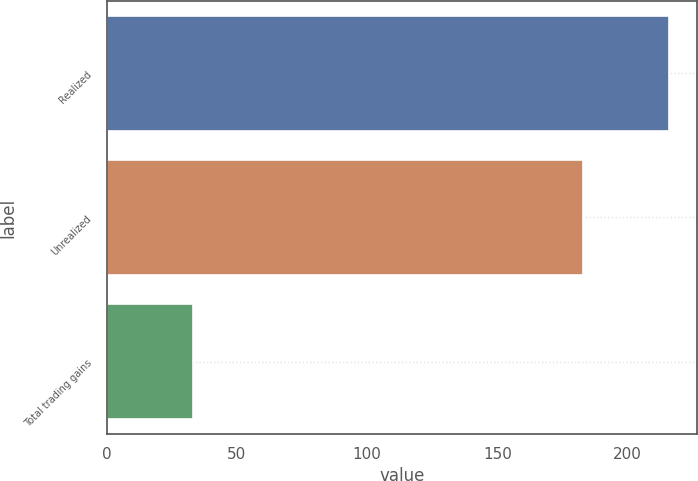Convert chart. <chart><loc_0><loc_0><loc_500><loc_500><bar_chart><fcel>Realized<fcel>Unrealized<fcel>Total trading gains<nl><fcel>216<fcel>183<fcel>33<nl></chart> 